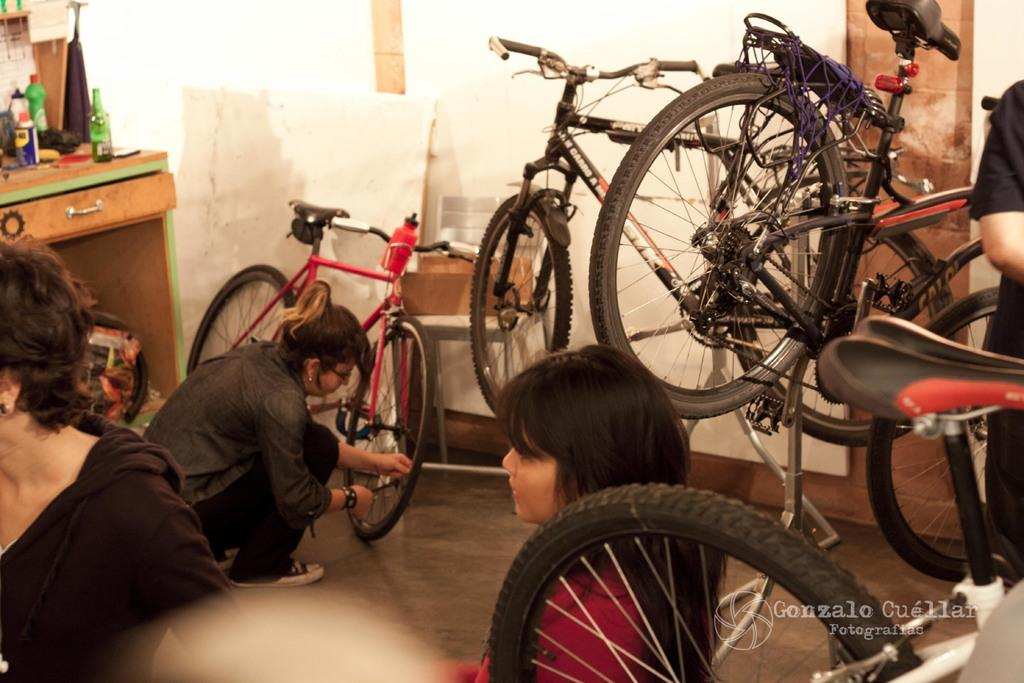Who or what can be seen in the image? There are persons in the image. What are the persons using in the image? There are bicycles in the image. What is the background of the image? There is a wall in the image. What object is on the left side of the image? There is a drawer table on the left side of the image. What is inside the drawer table? The drawer table contains bottles. What type of rock is being read by the person in the image? There is no rock or person reading in the image. 